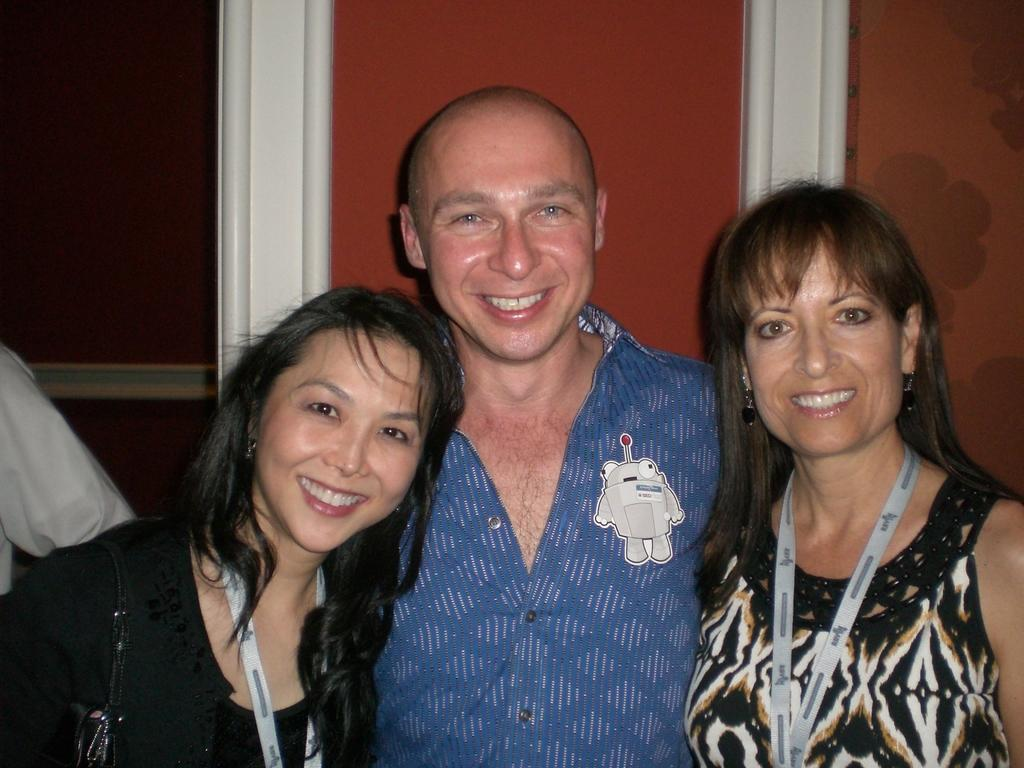How many people are in the image? There are three people in the image: a man and two women. What are the expressions on their faces? The man and women are smiling in the image. How are the man and women positioned in relation to each other? The man and women are standing together in the image. What can be seen in the background of the image? There is a wall in the background of the image. What type of story is the man telling the women in the image? There is no indication in the image that the man is telling a story to the women. 